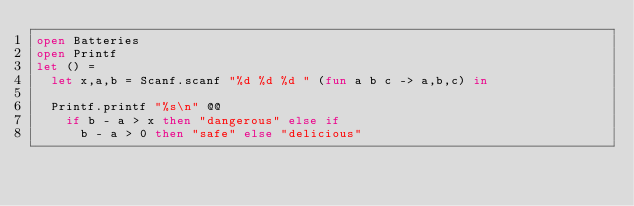<code> <loc_0><loc_0><loc_500><loc_500><_OCaml_>open Batteries
open Printf
let () =
  let x,a,b = Scanf.scanf "%d %d %d " (fun a b c -> a,b,c) in

  Printf.printf "%s\n" @@
    if b - a > x then "dangerous" else if
      b - a > 0 then "safe" else "delicious"
</code> 